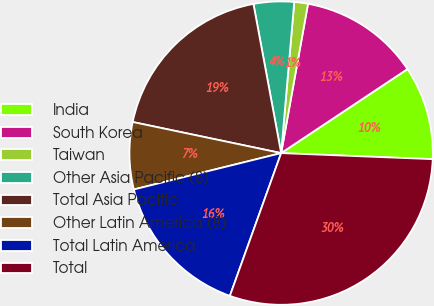Convert chart. <chart><loc_0><loc_0><loc_500><loc_500><pie_chart><fcel>India<fcel>South Korea<fcel>Taiwan<fcel>Other Asia Pacific (8)<fcel>Total Asia Pacific<fcel>Other Latin America (8)<fcel>Total Latin America<fcel>Total<nl><fcel>9.98%<fcel>12.82%<fcel>1.46%<fcel>4.3%<fcel>18.79%<fcel>7.14%<fcel>15.66%<fcel>29.85%<nl></chart> 